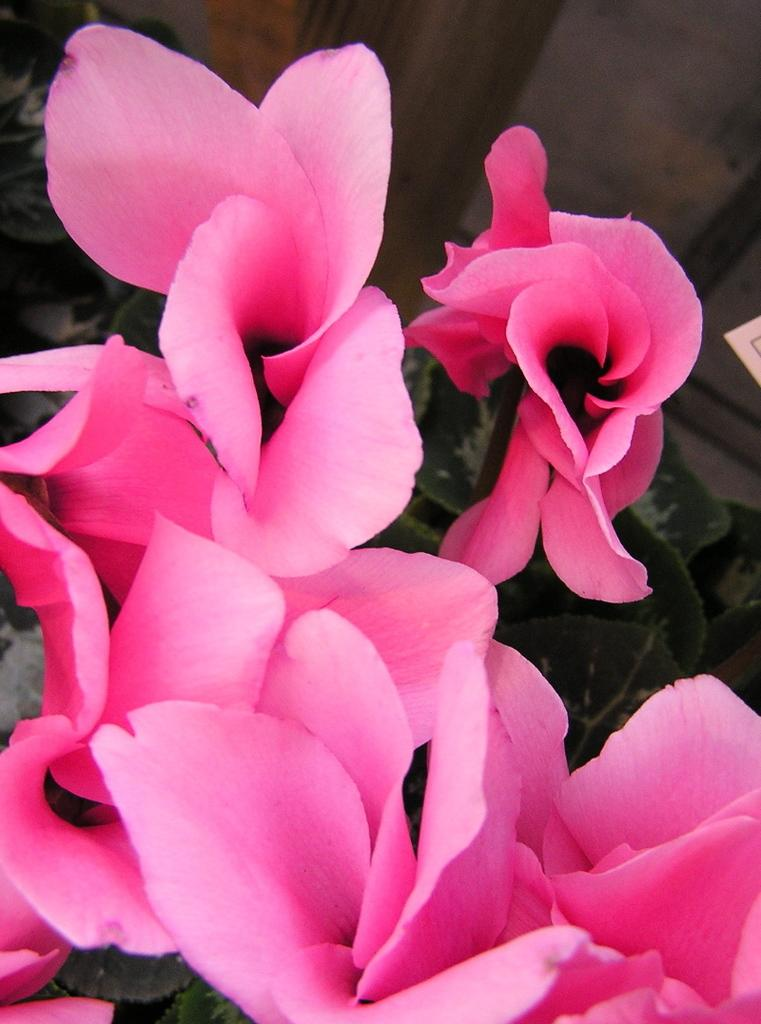What type of plant is visible in the image? There are: There are many flowers on a plant in the image. Can you describe the flowers on the plant? The flowers on the plant are numerous and visible in the image. What type of dish is being cooked in the image? There is no dish or cooking activity present in the image; it features a plant with many flowers. Is there a birthday celebration happening in the image? There is no indication of a birthday celebration in the image; it features a plant with many flowers. 